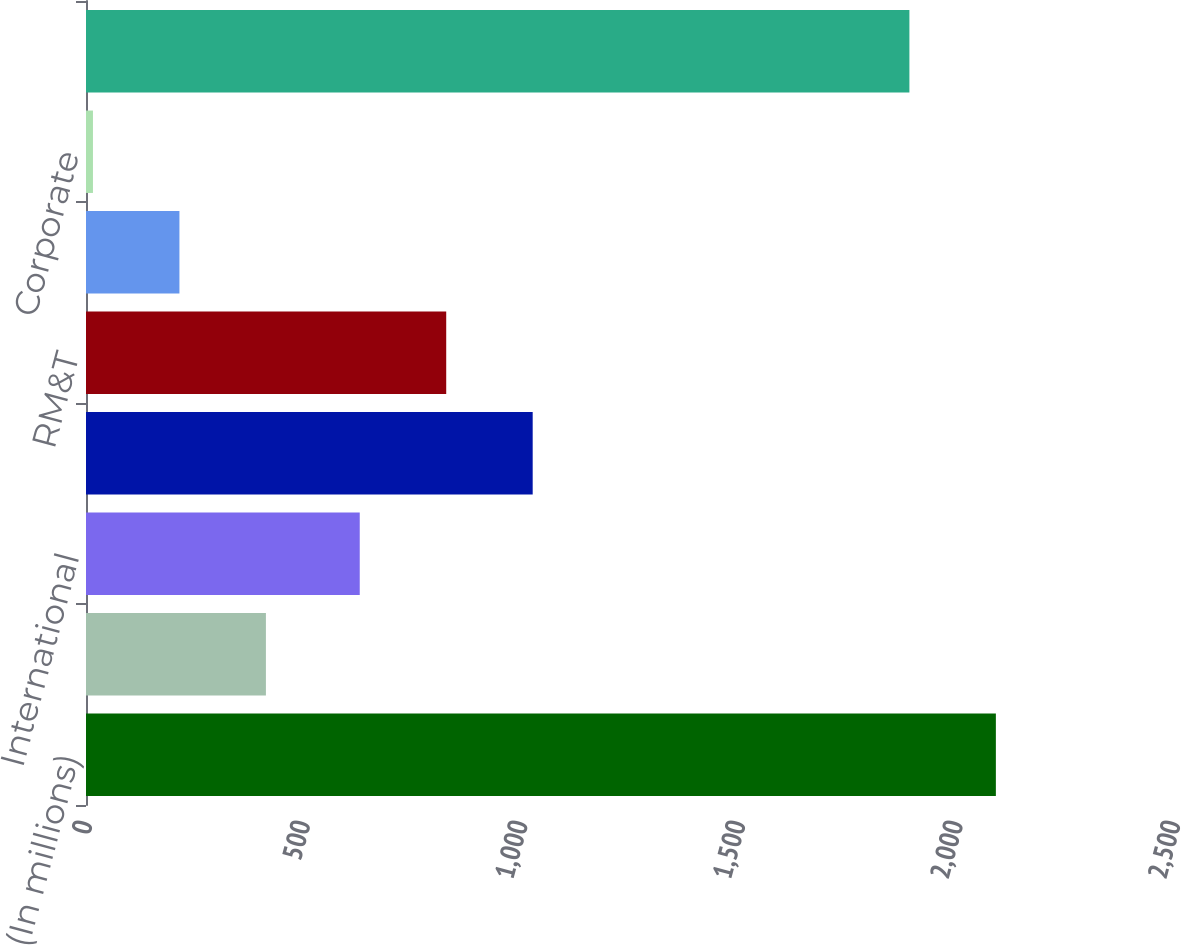<chart> <loc_0><loc_0><loc_500><loc_500><bar_chart><fcel>(In millions)<fcel>Domestic<fcel>International<fcel>Total E&P<fcel>RM&T<fcel>IG<fcel>Corporate<fcel>Total<nl><fcel>2090.7<fcel>413.4<fcel>629<fcel>1026.4<fcel>827.7<fcel>214.7<fcel>16<fcel>1892<nl></chart> 